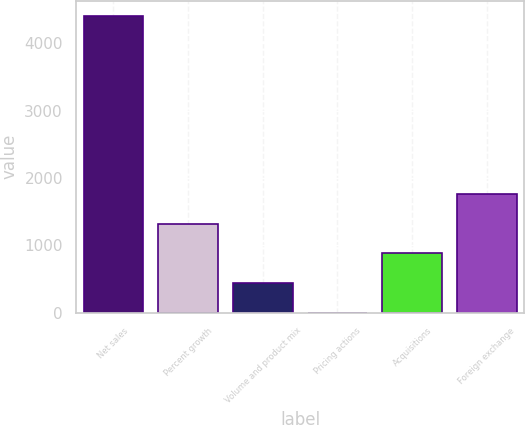Convert chart. <chart><loc_0><loc_0><loc_500><loc_500><bar_chart><fcel>Net sales<fcel>Percent growth<fcel>Volume and product mix<fcel>Pricing actions<fcel>Acquisitions<fcel>Foreign exchange<nl><fcel>4411.5<fcel>1324.5<fcel>442.5<fcel>1.5<fcel>883.5<fcel>1765.5<nl></chart> 